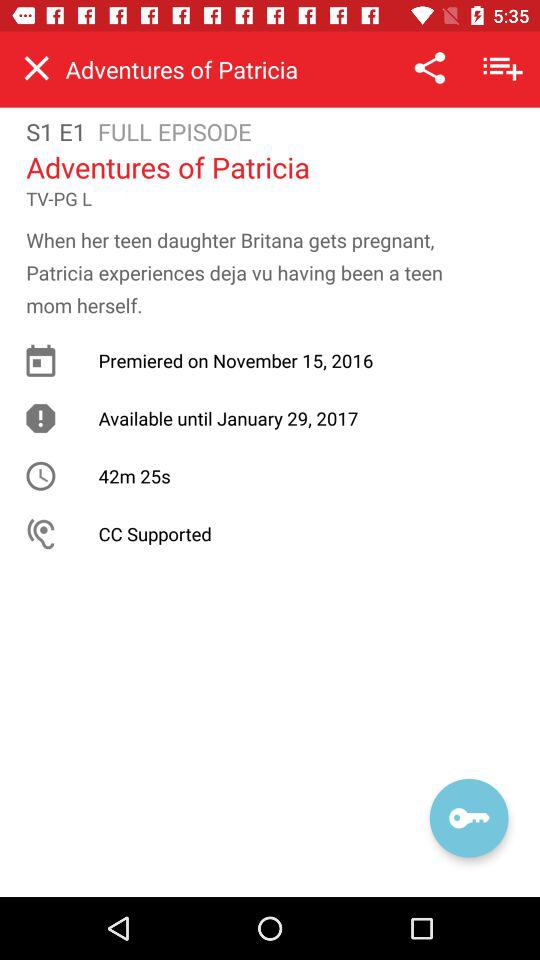The series premiered on which date? The series premiered on November 15, 2016. 